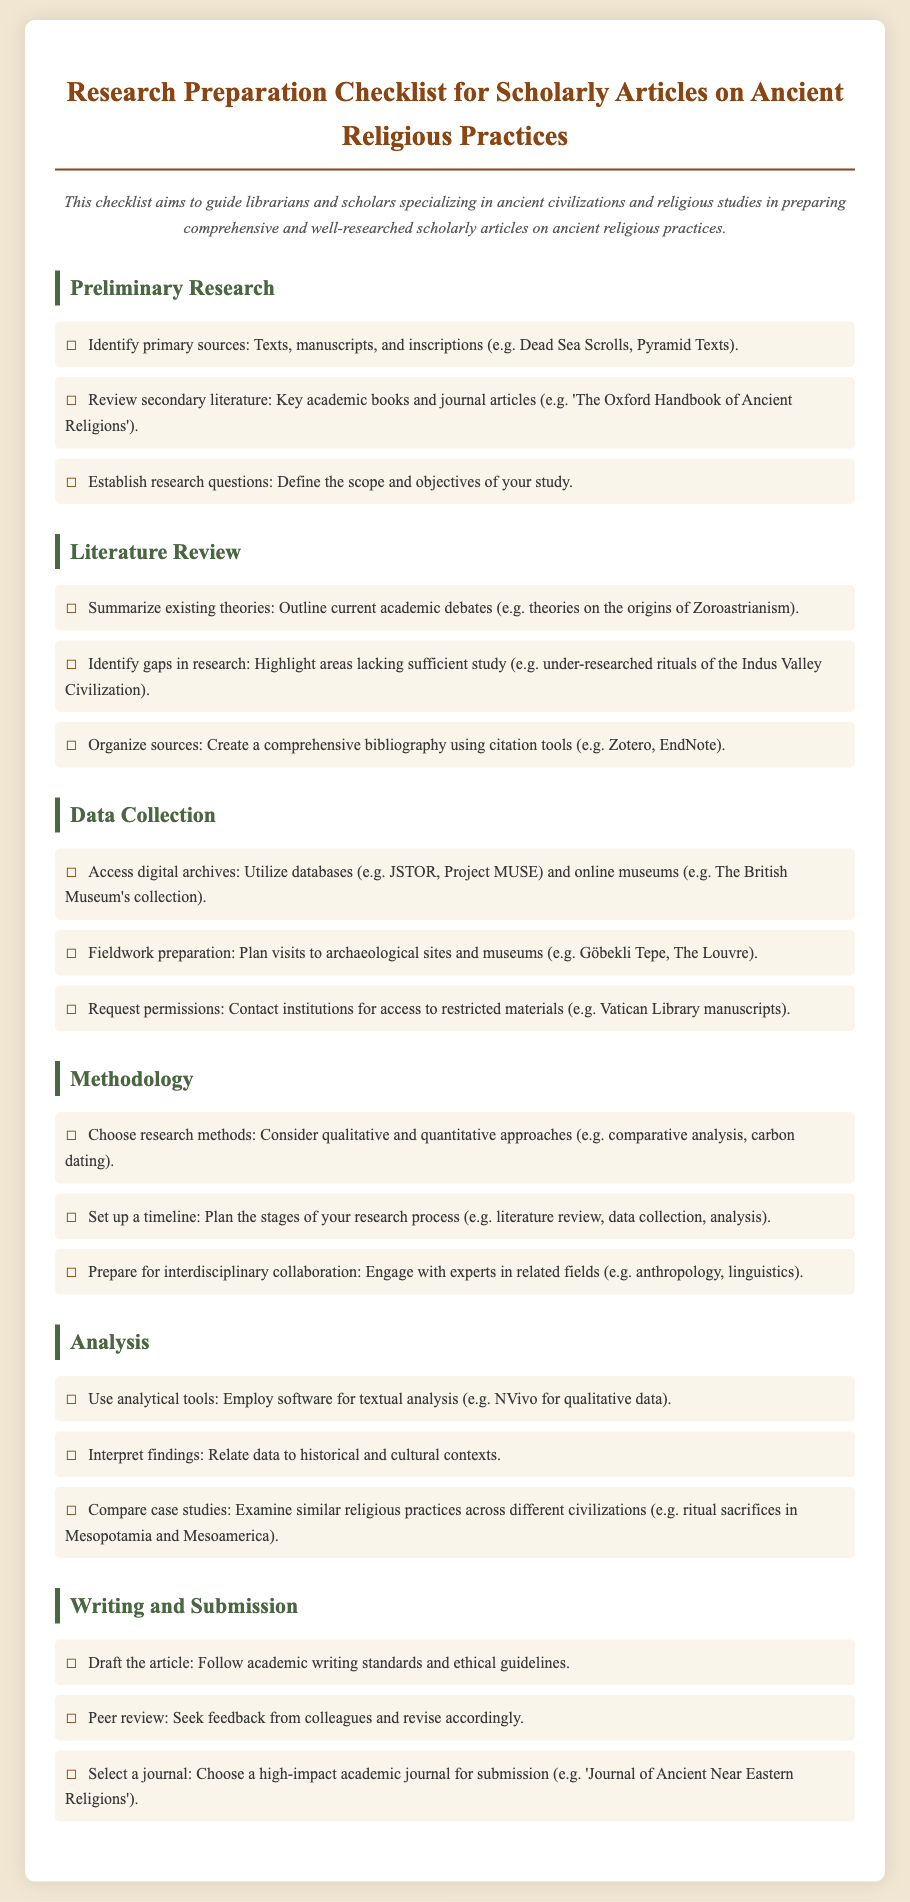what is the title of the checklist? The title of the checklist is given at the top of the document and summarizes its focus on scholarly articles regarding ancient religious practices.
Answer: Research Preparation Checklist for Scholarly Articles on Ancient Religious Practices who published 'The Oxford Handbook of Ancient Religions'? This reference is listed as part of the secondary literature that should be reviewed; it indicates a key academic book.
Answer: Unknown publisher which ancient texts are mentioned as primary sources? The document specifically mentions certain ancient texts as examples of primary sources relevant to the study of ancient religious practices.
Answer: Dead Sea Scrolls, Pyramid Texts what is one method for data collection mentioned? The checklist provides several methods, one of which involves accessing certain types of repositories or databases relevant for research.
Answer: Access digital archives what is a recommended analytical tool for qualitative data? The checklist specifies an analytical tool to enhance the research process and analysis of qualitative data related to ancient religious practices.
Answer: NVivo what stage follows the literature review in the research timeline? The progression of the research process is structured, with each stage building upon the previous one, indicating a clear path for researchers.
Answer: Data collection which type of collaboration should researchers prepare for? The document highlights the importance of collaboration in the research process, emphasizing interdisciplinary engagement.
Answer: Interdisciplinary collaboration what is a crucial component of the writing phase? The checklist outlines important practices in the academic writing process, emphasizing adherence to specific standards.
Answer: Draft the article 